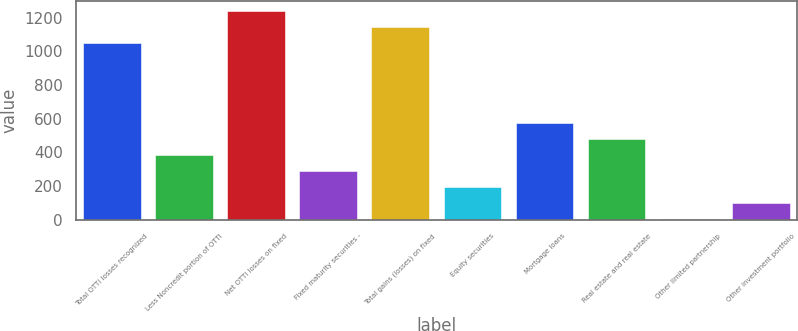Convert chart. <chart><loc_0><loc_0><loc_500><loc_500><bar_chart><fcel>Total OTTI losses recognized<fcel>Less Noncredit portion of OTTI<fcel>Net OTTI losses on fixed<fcel>Fixed maturity securities -<fcel>Total gains (losses) on fixed<fcel>Equity securities<fcel>Mortgage loans<fcel>Real estate and real estate<fcel>Other limited partnership<fcel>Other investment portfolio<nl><fcel>1050.1<fcel>384.4<fcel>1240.3<fcel>289.3<fcel>1145.2<fcel>194.2<fcel>574.6<fcel>479.5<fcel>4<fcel>99.1<nl></chart> 